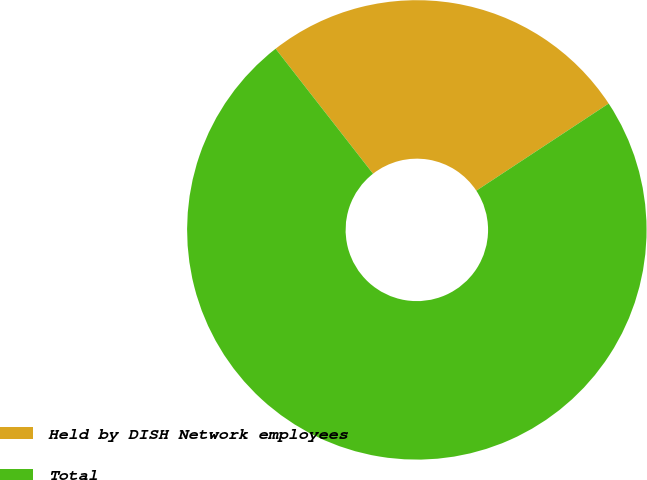Convert chart. <chart><loc_0><loc_0><loc_500><loc_500><pie_chart><fcel>Held by DISH Network employees<fcel>Total<nl><fcel>26.27%<fcel>73.73%<nl></chart> 